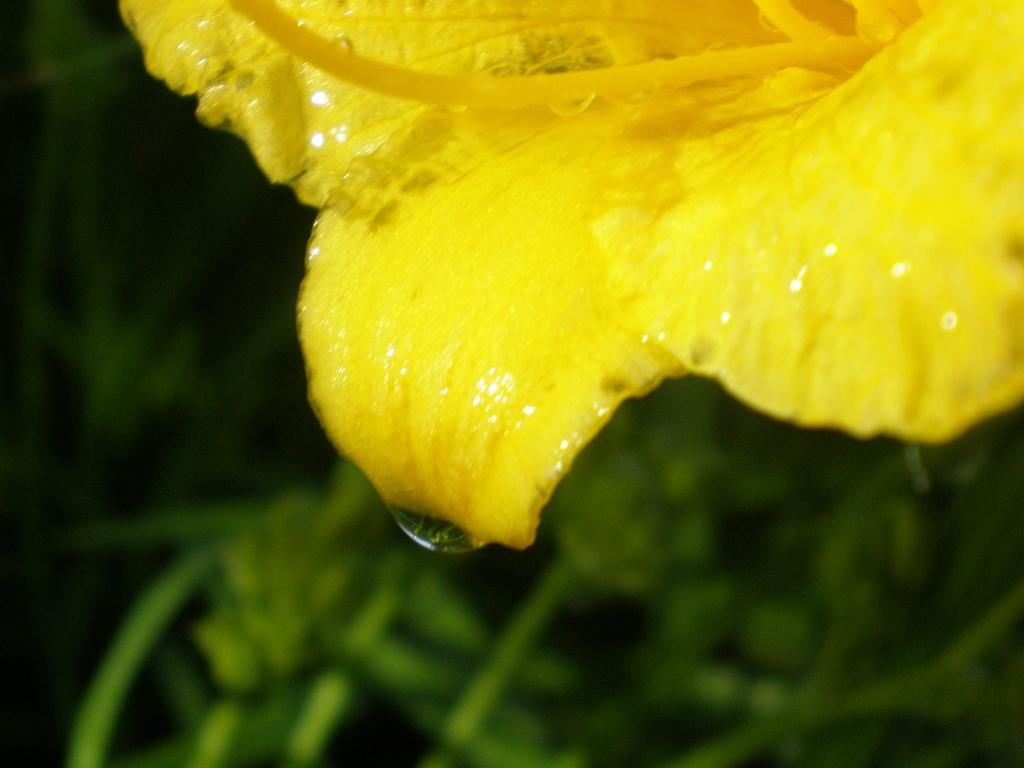What type of flower can be seen in the image? There is a yellow color flower in the image. What else can be seen in the background of the image? There are plants in the background of the image. Where is the nest located in the image? There is no nest present in the image. What type of air is visible in the image? The image does not depict any specific type of air; it simply shows a flower and plants. 